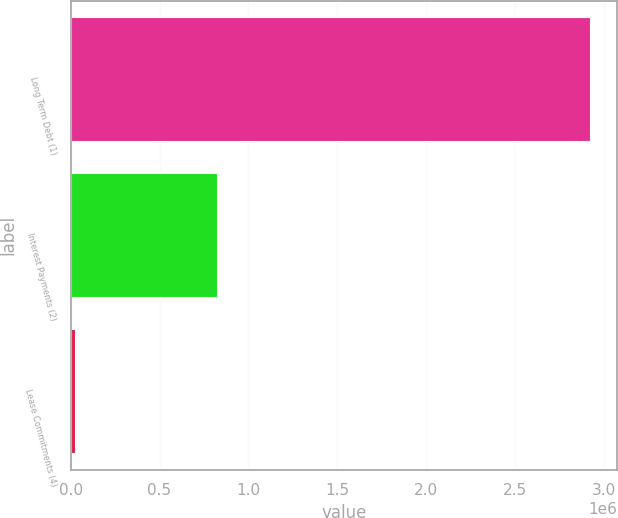<chart> <loc_0><loc_0><loc_500><loc_500><bar_chart><fcel>Long Term Debt (1)<fcel>Interest Payments (2)<fcel>Lease Commitments (4)<nl><fcel>2.92858e+06<fcel>827835<fcel>30474<nl></chart> 